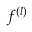<formula> <loc_0><loc_0><loc_500><loc_500>f ^ { ( l ) }</formula> 